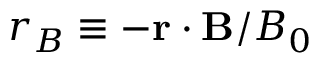Convert formula to latex. <formula><loc_0><loc_0><loc_500><loc_500>r _ { B } \equiv - r \cdot B / B _ { 0 }</formula> 